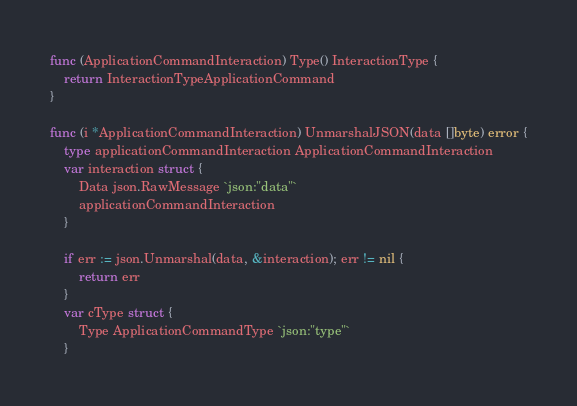<code> <loc_0><loc_0><loc_500><loc_500><_Go_>func (ApplicationCommandInteraction) Type() InteractionType {
	return InteractionTypeApplicationCommand
}

func (i *ApplicationCommandInteraction) UnmarshalJSON(data []byte) error {
	type applicationCommandInteraction ApplicationCommandInteraction
	var interaction struct {
		Data json.RawMessage `json:"data"`
		applicationCommandInteraction
	}

	if err := json.Unmarshal(data, &interaction); err != nil {
		return err
	}
	var cType struct {
		Type ApplicationCommandType `json:"type"`
	}</code> 